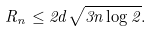<formula> <loc_0><loc_0><loc_500><loc_500>R _ { n } \leq 2 d \sqrt { 3 n \log 2 } .</formula> 